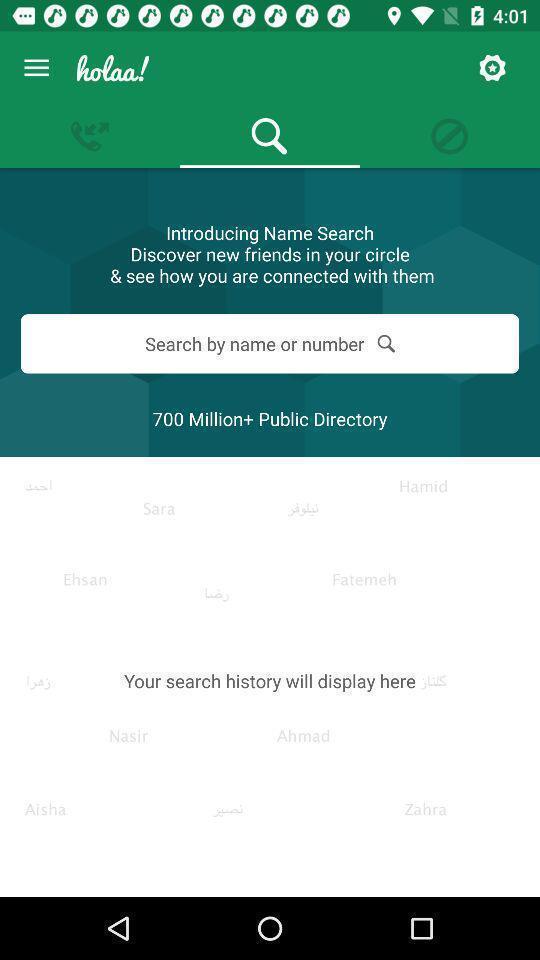Give me a summary of this screen capture. Search page of a call history. 